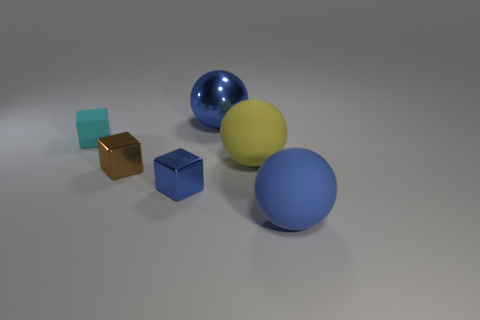Can you describe the lighting and shadows in the scene? The lighting in the scene comes from above, as indicated by the soft shadows cast directly beneath each object. The shadows are gentle and diffuse, suggesting that the light source is probably large or there might be multiple sources contributing to the ambient lighting. This soft light accentuates the objects' shapes and textures. Does the lighting reveal anything about the setting? While specific details of the setting are not visible, the lighting and shadows suggest the objects are being lit in a controlled environment, likely indoors. It resembles studio lighting, which could indicate a setting designed for photographing or displaying the objects in a way that highlights their form and color. 